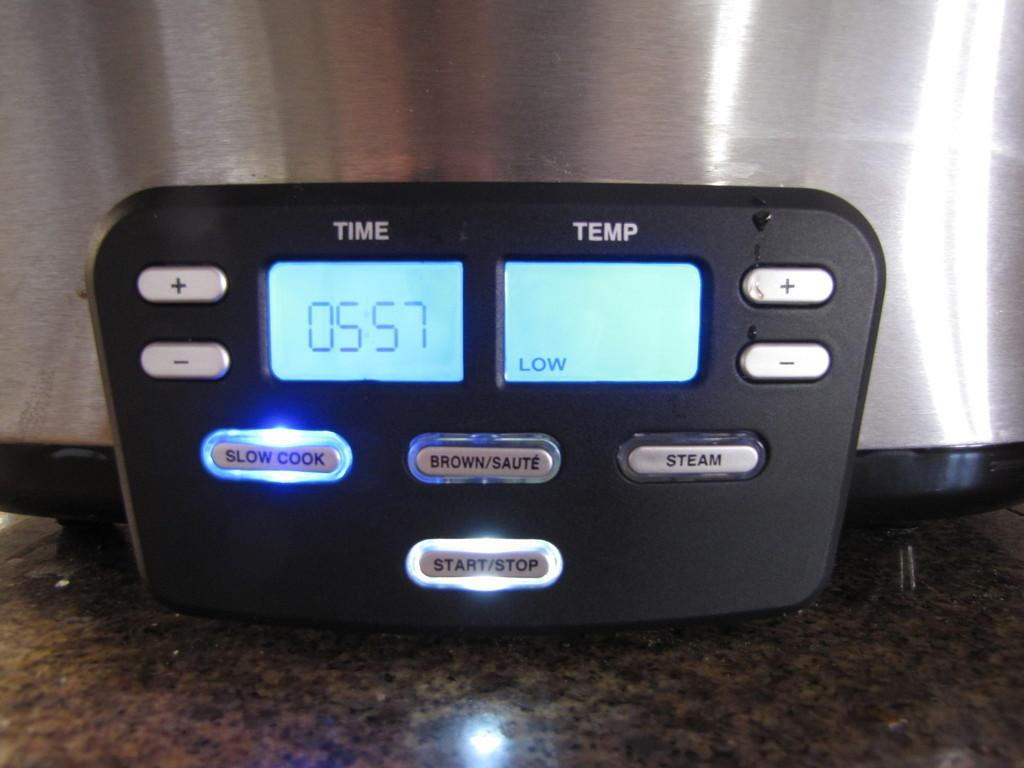Provide a one-sentence caption for the provided image. A cookware display shows that it is cooking at low temperature. 